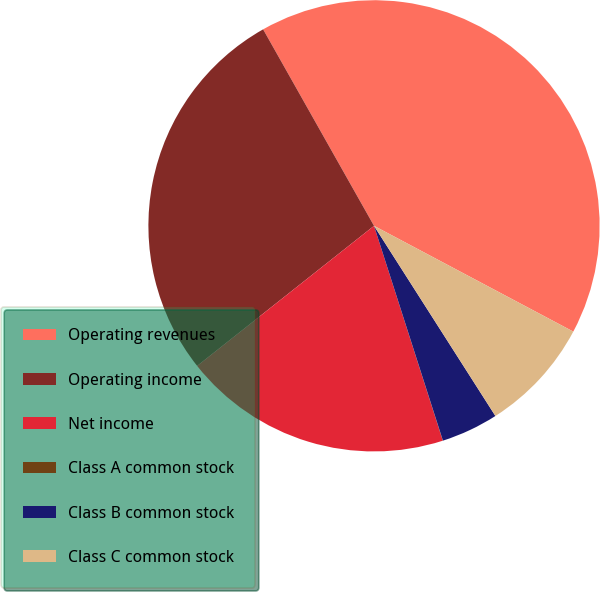<chart> <loc_0><loc_0><loc_500><loc_500><pie_chart><fcel>Operating revenues<fcel>Operating income<fcel>Net income<fcel>Class A common stock<fcel>Class B common stock<fcel>Class C common stock<nl><fcel>40.94%<fcel>27.48%<fcel>19.27%<fcel>0.01%<fcel>4.1%<fcel>8.19%<nl></chart> 